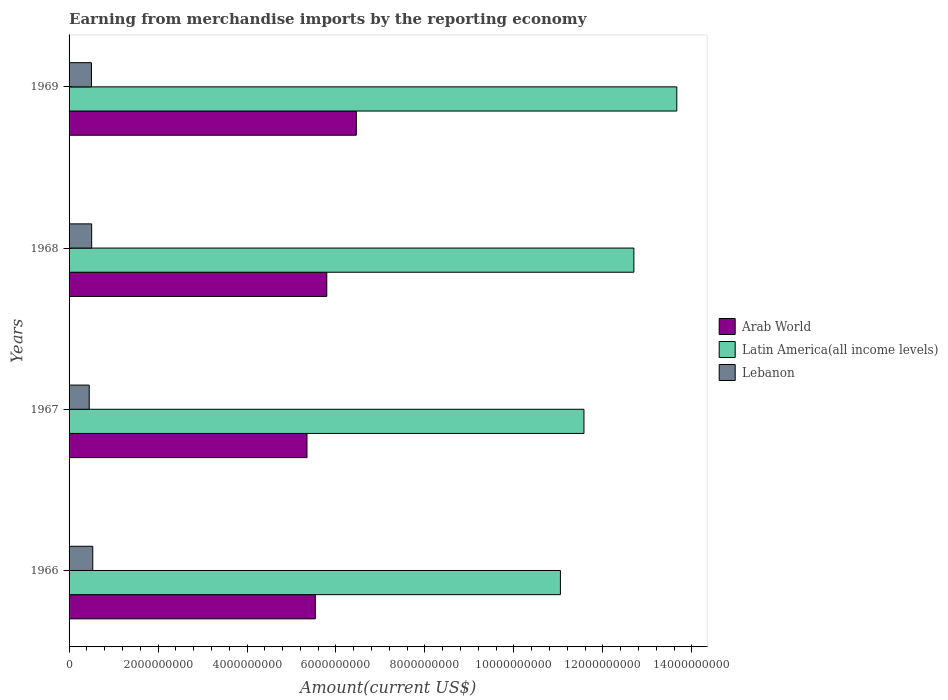How many different coloured bars are there?
Provide a succinct answer. 3. Are the number of bars per tick equal to the number of legend labels?
Your answer should be very brief. Yes. Are the number of bars on each tick of the Y-axis equal?
Make the answer very short. Yes. How many bars are there on the 2nd tick from the top?
Make the answer very short. 3. What is the label of the 4th group of bars from the top?
Make the answer very short. 1966. In how many cases, is the number of bars for a given year not equal to the number of legend labels?
Offer a very short reply. 0. What is the amount earned from merchandise imports in Latin America(all income levels) in 1969?
Your answer should be compact. 1.37e+1. Across all years, what is the maximum amount earned from merchandise imports in Arab World?
Your answer should be very brief. 6.46e+09. Across all years, what is the minimum amount earned from merchandise imports in Arab World?
Your answer should be very brief. 5.35e+09. In which year was the amount earned from merchandise imports in Latin America(all income levels) maximum?
Provide a short and direct response. 1969. In which year was the amount earned from merchandise imports in Latin America(all income levels) minimum?
Make the answer very short. 1966. What is the total amount earned from merchandise imports in Arab World in the graph?
Keep it short and to the point. 2.31e+1. What is the difference between the amount earned from merchandise imports in Arab World in 1966 and that in 1967?
Provide a succinct answer. 1.88e+08. What is the difference between the amount earned from merchandise imports in Arab World in 1967 and the amount earned from merchandise imports in Lebanon in 1969?
Make the answer very short. 4.85e+09. What is the average amount earned from merchandise imports in Lebanon per year?
Provide a short and direct response. 4.99e+08. In the year 1967, what is the difference between the amount earned from merchandise imports in Arab World and amount earned from merchandise imports in Lebanon?
Your response must be concise. 4.90e+09. What is the ratio of the amount earned from merchandise imports in Lebanon in 1966 to that in 1968?
Provide a short and direct response. 1.05. What is the difference between the highest and the second highest amount earned from merchandise imports in Arab World?
Offer a terse response. 6.65e+08. What is the difference between the highest and the lowest amount earned from merchandise imports in Latin America(all income levels)?
Offer a very short reply. 2.62e+09. What does the 1st bar from the top in 1969 represents?
Provide a short and direct response. Lebanon. What does the 2nd bar from the bottom in 1968 represents?
Give a very brief answer. Latin America(all income levels). Is it the case that in every year, the sum of the amount earned from merchandise imports in Arab World and amount earned from merchandise imports in Latin America(all income levels) is greater than the amount earned from merchandise imports in Lebanon?
Provide a succinct answer. Yes. Are all the bars in the graph horizontal?
Keep it short and to the point. Yes. What is the difference between two consecutive major ticks on the X-axis?
Provide a short and direct response. 2.00e+09. Are the values on the major ticks of X-axis written in scientific E-notation?
Make the answer very short. No. Does the graph contain grids?
Provide a short and direct response. No. How many legend labels are there?
Make the answer very short. 3. How are the legend labels stacked?
Ensure brevity in your answer.  Vertical. What is the title of the graph?
Offer a very short reply. Earning from merchandise imports by the reporting economy. What is the label or title of the X-axis?
Offer a terse response. Amount(current US$). What is the label or title of the Y-axis?
Keep it short and to the point. Years. What is the Amount(current US$) in Arab World in 1966?
Ensure brevity in your answer.  5.54e+09. What is the Amount(current US$) in Latin America(all income levels) in 1966?
Your answer should be compact. 1.10e+1. What is the Amount(current US$) of Lebanon in 1966?
Provide a short and direct response. 5.33e+08. What is the Amount(current US$) in Arab World in 1967?
Provide a short and direct response. 5.35e+09. What is the Amount(current US$) of Latin America(all income levels) in 1967?
Provide a short and direct response. 1.16e+1. What is the Amount(current US$) of Lebanon in 1967?
Your response must be concise. 4.53e+08. What is the Amount(current US$) of Arab World in 1968?
Provide a succinct answer. 5.79e+09. What is the Amount(current US$) in Latin America(all income levels) in 1968?
Your response must be concise. 1.27e+1. What is the Amount(current US$) in Lebanon in 1968?
Make the answer very short. 5.08e+08. What is the Amount(current US$) of Arab World in 1969?
Make the answer very short. 6.46e+09. What is the Amount(current US$) in Latin America(all income levels) in 1969?
Make the answer very short. 1.37e+1. What is the Amount(current US$) in Lebanon in 1969?
Offer a terse response. 5.03e+08. Across all years, what is the maximum Amount(current US$) in Arab World?
Offer a very short reply. 6.46e+09. Across all years, what is the maximum Amount(current US$) in Latin America(all income levels)?
Your answer should be very brief. 1.37e+1. Across all years, what is the maximum Amount(current US$) in Lebanon?
Offer a terse response. 5.33e+08. Across all years, what is the minimum Amount(current US$) in Arab World?
Give a very brief answer. 5.35e+09. Across all years, what is the minimum Amount(current US$) of Latin America(all income levels)?
Provide a succinct answer. 1.10e+1. Across all years, what is the minimum Amount(current US$) in Lebanon?
Provide a succinct answer. 4.53e+08. What is the total Amount(current US$) in Arab World in the graph?
Your answer should be compact. 2.31e+1. What is the total Amount(current US$) of Latin America(all income levels) in the graph?
Your answer should be very brief. 4.90e+1. What is the total Amount(current US$) in Lebanon in the graph?
Ensure brevity in your answer.  2.00e+09. What is the difference between the Amount(current US$) in Arab World in 1966 and that in 1967?
Give a very brief answer. 1.88e+08. What is the difference between the Amount(current US$) of Latin America(all income levels) in 1966 and that in 1967?
Your answer should be very brief. -5.30e+08. What is the difference between the Amount(current US$) of Lebanon in 1966 and that in 1967?
Your response must be concise. 7.98e+07. What is the difference between the Amount(current US$) of Arab World in 1966 and that in 1968?
Give a very brief answer. -2.57e+08. What is the difference between the Amount(current US$) in Latin America(all income levels) in 1966 and that in 1968?
Keep it short and to the point. -1.65e+09. What is the difference between the Amount(current US$) of Lebanon in 1966 and that in 1968?
Provide a short and direct response. 2.48e+07. What is the difference between the Amount(current US$) of Arab World in 1966 and that in 1969?
Give a very brief answer. -9.22e+08. What is the difference between the Amount(current US$) of Latin America(all income levels) in 1966 and that in 1969?
Keep it short and to the point. -2.62e+09. What is the difference between the Amount(current US$) of Lebanon in 1966 and that in 1969?
Give a very brief answer. 2.98e+07. What is the difference between the Amount(current US$) in Arab World in 1967 and that in 1968?
Offer a very short reply. -4.45e+08. What is the difference between the Amount(current US$) in Latin America(all income levels) in 1967 and that in 1968?
Make the answer very short. -1.12e+09. What is the difference between the Amount(current US$) in Lebanon in 1967 and that in 1968?
Your answer should be very brief. -5.50e+07. What is the difference between the Amount(current US$) of Arab World in 1967 and that in 1969?
Keep it short and to the point. -1.11e+09. What is the difference between the Amount(current US$) of Latin America(all income levels) in 1967 and that in 1969?
Your answer should be compact. -2.09e+09. What is the difference between the Amount(current US$) in Lebanon in 1967 and that in 1969?
Offer a very short reply. -5.00e+07. What is the difference between the Amount(current US$) in Arab World in 1968 and that in 1969?
Your answer should be very brief. -6.65e+08. What is the difference between the Amount(current US$) in Latin America(all income levels) in 1968 and that in 1969?
Ensure brevity in your answer.  -9.65e+08. What is the difference between the Amount(current US$) of Lebanon in 1968 and that in 1969?
Provide a succinct answer. 4.95e+06. What is the difference between the Amount(current US$) of Arab World in 1966 and the Amount(current US$) of Latin America(all income levels) in 1967?
Your response must be concise. -6.04e+09. What is the difference between the Amount(current US$) in Arab World in 1966 and the Amount(current US$) in Lebanon in 1967?
Keep it short and to the point. 5.08e+09. What is the difference between the Amount(current US$) of Latin America(all income levels) in 1966 and the Amount(current US$) of Lebanon in 1967?
Your response must be concise. 1.06e+1. What is the difference between the Amount(current US$) of Arab World in 1966 and the Amount(current US$) of Latin America(all income levels) in 1968?
Your answer should be very brief. -7.16e+09. What is the difference between the Amount(current US$) in Arab World in 1966 and the Amount(current US$) in Lebanon in 1968?
Ensure brevity in your answer.  5.03e+09. What is the difference between the Amount(current US$) of Latin America(all income levels) in 1966 and the Amount(current US$) of Lebanon in 1968?
Your response must be concise. 1.05e+1. What is the difference between the Amount(current US$) in Arab World in 1966 and the Amount(current US$) in Latin America(all income levels) in 1969?
Ensure brevity in your answer.  -8.13e+09. What is the difference between the Amount(current US$) in Arab World in 1966 and the Amount(current US$) in Lebanon in 1969?
Provide a succinct answer. 5.03e+09. What is the difference between the Amount(current US$) in Latin America(all income levels) in 1966 and the Amount(current US$) in Lebanon in 1969?
Ensure brevity in your answer.  1.05e+1. What is the difference between the Amount(current US$) of Arab World in 1967 and the Amount(current US$) of Latin America(all income levels) in 1968?
Offer a terse response. -7.35e+09. What is the difference between the Amount(current US$) in Arab World in 1967 and the Amount(current US$) in Lebanon in 1968?
Your answer should be very brief. 4.84e+09. What is the difference between the Amount(current US$) in Latin America(all income levels) in 1967 and the Amount(current US$) in Lebanon in 1968?
Your answer should be very brief. 1.11e+1. What is the difference between the Amount(current US$) in Arab World in 1967 and the Amount(current US$) in Latin America(all income levels) in 1969?
Provide a short and direct response. -8.31e+09. What is the difference between the Amount(current US$) in Arab World in 1967 and the Amount(current US$) in Lebanon in 1969?
Give a very brief answer. 4.85e+09. What is the difference between the Amount(current US$) in Latin America(all income levels) in 1967 and the Amount(current US$) in Lebanon in 1969?
Provide a short and direct response. 1.11e+1. What is the difference between the Amount(current US$) in Arab World in 1968 and the Amount(current US$) in Latin America(all income levels) in 1969?
Make the answer very short. -7.87e+09. What is the difference between the Amount(current US$) in Arab World in 1968 and the Amount(current US$) in Lebanon in 1969?
Provide a succinct answer. 5.29e+09. What is the difference between the Amount(current US$) in Latin America(all income levels) in 1968 and the Amount(current US$) in Lebanon in 1969?
Keep it short and to the point. 1.22e+1. What is the average Amount(current US$) in Arab World per year?
Offer a terse response. 5.78e+09. What is the average Amount(current US$) in Latin America(all income levels) per year?
Offer a very short reply. 1.22e+1. What is the average Amount(current US$) in Lebanon per year?
Offer a very short reply. 4.99e+08. In the year 1966, what is the difference between the Amount(current US$) in Arab World and Amount(current US$) in Latin America(all income levels)?
Your response must be concise. -5.51e+09. In the year 1966, what is the difference between the Amount(current US$) in Arab World and Amount(current US$) in Lebanon?
Provide a short and direct response. 5.00e+09. In the year 1966, what is the difference between the Amount(current US$) of Latin America(all income levels) and Amount(current US$) of Lebanon?
Provide a short and direct response. 1.05e+1. In the year 1967, what is the difference between the Amount(current US$) of Arab World and Amount(current US$) of Latin America(all income levels)?
Provide a short and direct response. -6.23e+09. In the year 1967, what is the difference between the Amount(current US$) of Arab World and Amount(current US$) of Lebanon?
Ensure brevity in your answer.  4.90e+09. In the year 1967, what is the difference between the Amount(current US$) of Latin America(all income levels) and Amount(current US$) of Lebanon?
Ensure brevity in your answer.  1.11e+1. In the year 1968, what is the difference between the Amount(current US$) in Arab World and Amount(current US$) in Latin America(all income levels)?
Keep it short and to the point. -6.90e+09. In the year 1968, what is the difference between the Amount(current US$) of Arab World and Amount(current US$) of Lebanon?
Provide a short and direct response. 5.29e+09. In the year 1968, what is the difference between the Amount(current US$) in Latin America(all income levels) and Amount(current US$) in Lebanon?
Provide a short and direct response. 1.22e+1. In the year 1969, what is the difference between the Amount(current US$) of Arab World and Amount(current US$) of Latin America(all income levels)?
Your answer should be compact. -7.20e+09. In the year 1969, what is the difference between the Amount(current US$) in Arab World and Amount(current US$) in Lebanon?
Your answer should be very brief. 5.95e+09. In the year 1969, what is the difference between the Amount(current US$) in Latin America(all income levels) and Amount(current US$) in Lebanon?
Offer a terse response. 1.32e+1. What is the ratio of the Amount(current US$) in Arab World in 1966 to that in 1967?
Provide a short and direct response. 1.04. What is the ratio of the Amount(current US$) in Latin America(all income levels) in 1966 to that in 1967?
Your response must be concise. 0.95. What is the ratio of the Amount(current US$) in Lebanon in 1966 to that in 1967?
Offer a very short reply. 1.18. What is the ratio of the Amount(current US$) in Arab World in 1966 to that in 1968?
Keep it short and to the point. 0.96. What is the ratio of the Amount(current US$) in Latin America(all income levels) in 1966 to that in 1968?
Provide a short and direct response. 0.87. What is the ratio of the Amount(current US$) in Lebanon in 1966 to that in 1968?
Provide a succinct answer. 1.05. What is the ratio of the Amount(current US$) of Arab World in 1966 to that in 1969?
Offer a very short reply. 0.86. What is the ratio of the Amount(current US$) in Latin America(all income levels) in 1966 to that in 1969?
Provide a short and direct response. 0.81. What is the ratio of the Amount(current US$) in Lebanon in 1966 to that in 1969?
Offer a very short reply. 1.06. What is the ratio of the Amount(current US$) in Arab World in 1967 to that in 1968?
Provide a succinct answer. 0.92. What is the ratio of the Amount(current US$) in Latin America(all income levels) in 1967 to that in 1968?
Make the answer very short. 0.91. What is the ratio of the Amount(current US$) of Lebanon in 1967 to that in 1968?
Offer a terse response. 0.89. What is the ratio of the Amount(current US$) in Arab World in 1967 to that in 1969?
Your answer should be very brief. 0.83. What is the ratio of the Amount(current US$) in Latin America(all income levels) in 1967 to that in 1969?
Keep it short and to the point. 0.85. What is the ratio of the Amount(current US$) in Lebanon in 1967 to that in 1969?
Keep it short and to the point. 0.9. What is the ratio of the Amount(current US$) in Arab World in 1968 to that in 1969?
Your answer should be compact. 0.9. What is the ratio of the Amount(current US$) of Latin America(all income levels) in 1968 to that in 1969?
Ensure brevity in your answer.  0.93. What is the ratio of the Amount(current US$) of Lebanon in 1968 to that in 1969?
Offer a very short reply. 1.01. What is the difference between the highest and the second highest Amount(current US$) in Arab World?
Give a very brief answer. 6.65e+08. What is the difference between the highest and the second highest Amount(current US$) in Latin America(all income levels)?
Make the answer very short. 9.65e+08. What is the difference between the highest and the second highest Amount(current US$) in Lebanon?
Your answer should be very brief. 2.48e+07. What is the difference between the highest and the lowest Amount(current US$) of Arab World?
Your response must be concise. 1.11e+09. What is the difference between the highest and the lowest Amount(current US$) in Latin America(all income levels)?
Ensure brevity in your answer.  2.62e+09. What is the difference between the highest and the lowest Amount(current US$) of Lebanon?
Offer a terse response. 7.98e+07. 